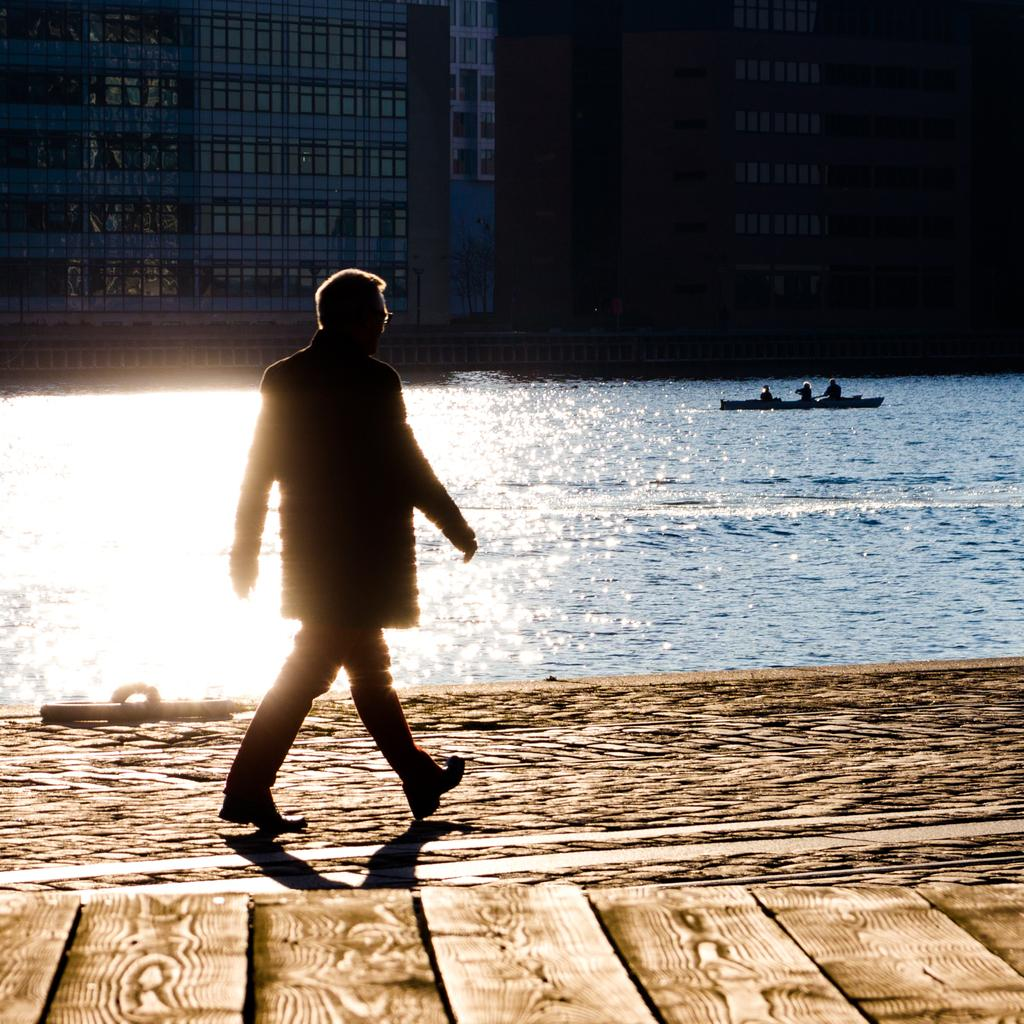What is the main subject of the image? There is a person standing in the image. What can be seen in the water in the image? There is a boat on the water in the image. What is visible in the background of the image? There are buildings in the background of the image. How many daughters does the person in the image have? There is no information about the person's daughters in the image, so it cannot be determined. 